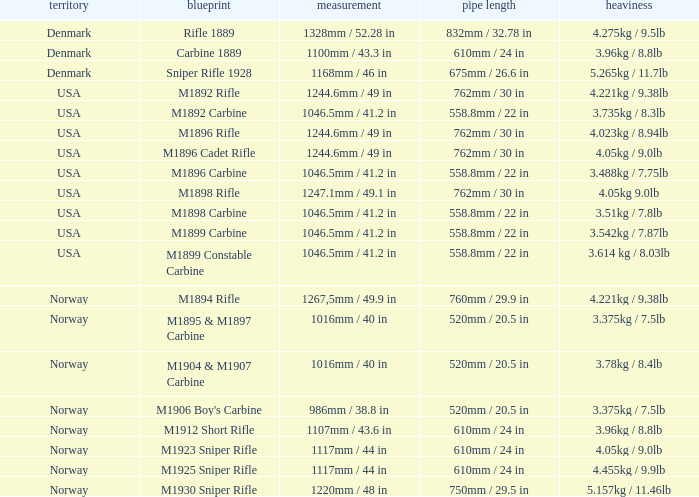What is Nation, when Model is M1895 & M1897 Carbine? Norway. 